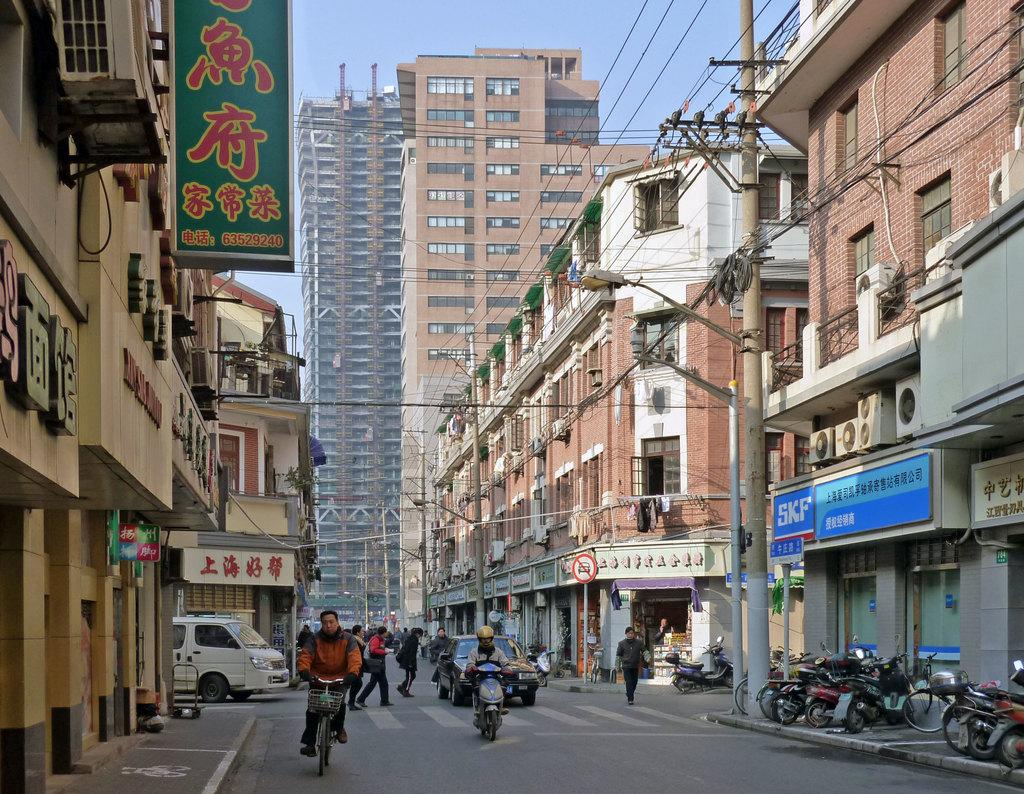What are the people in the image doing? The people in the image are walking. What are the two people on the vehicles doing? They are riding vehicles. What can be seen on the sides of the road in the image? There are boards visible in the image. What type of transportation is present in the image? Vehicles are present in the image. What is the surface on which the people and vehicles are moving? There is a road in the image. What is providing illumination in the image? Lights are visible in the image. What are the poles supporting in the image? Wires are visible in the image, which are supported by poles. What type of structures can be seen in the image? There are buildings in the image. What can be seen in the background of the image? The sky is visible in the background of the image. Can you see any nets in the image? There are no nets present in the image. Is there a body of water visible in the image? There is no body of water visible in the image. What type of animal can be seen interacting with the people in the image? There are no animals present in the image; it only features people, vehicles, and other inanimate objects. 